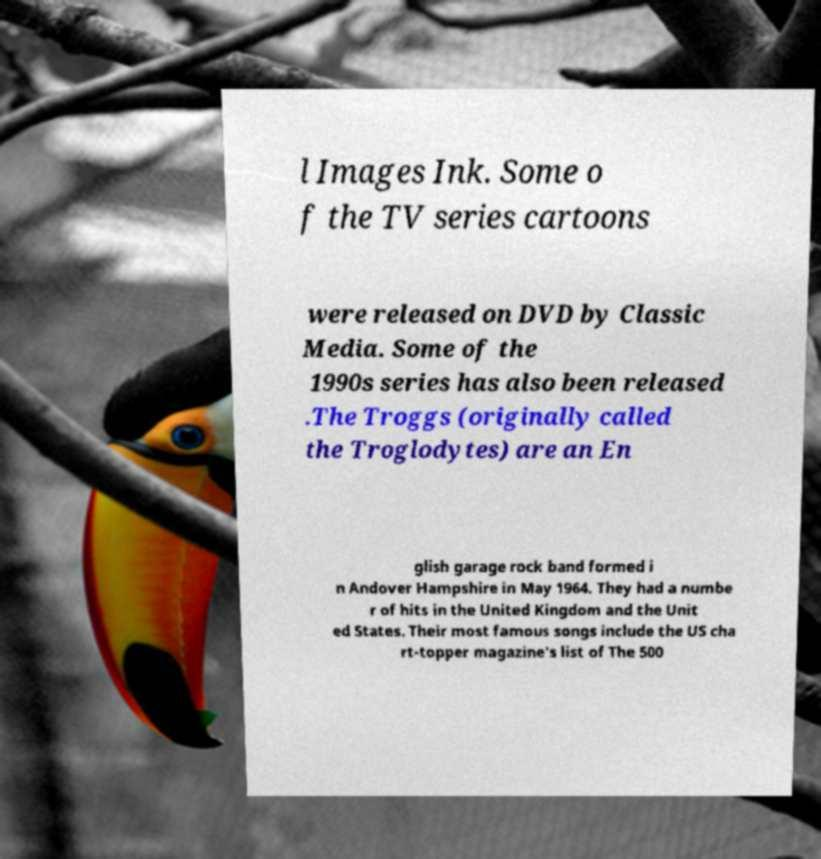Please read and relay the text visible in this image. What does it say? l Images Ink. Some o f the TV series cartoons were released on DVD by Classic Media. Some of the 1990s series has also been released .The Troggs (originally called the Troglodytes) are an En glish garage rock band formed i n Andover Hampshire in May 1964. They had a numbe r of hits in the United Kingdom and the Unit ed States. Their most famous songs include the US cha rt-topper magazine's list of The 500 